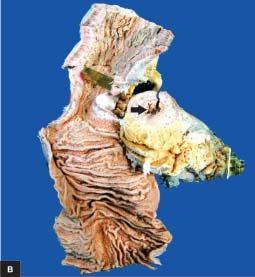what shows increased mesenteric fat, thickened wall and narrow lumen?
Answer the question using a single word or phrase. External surface 